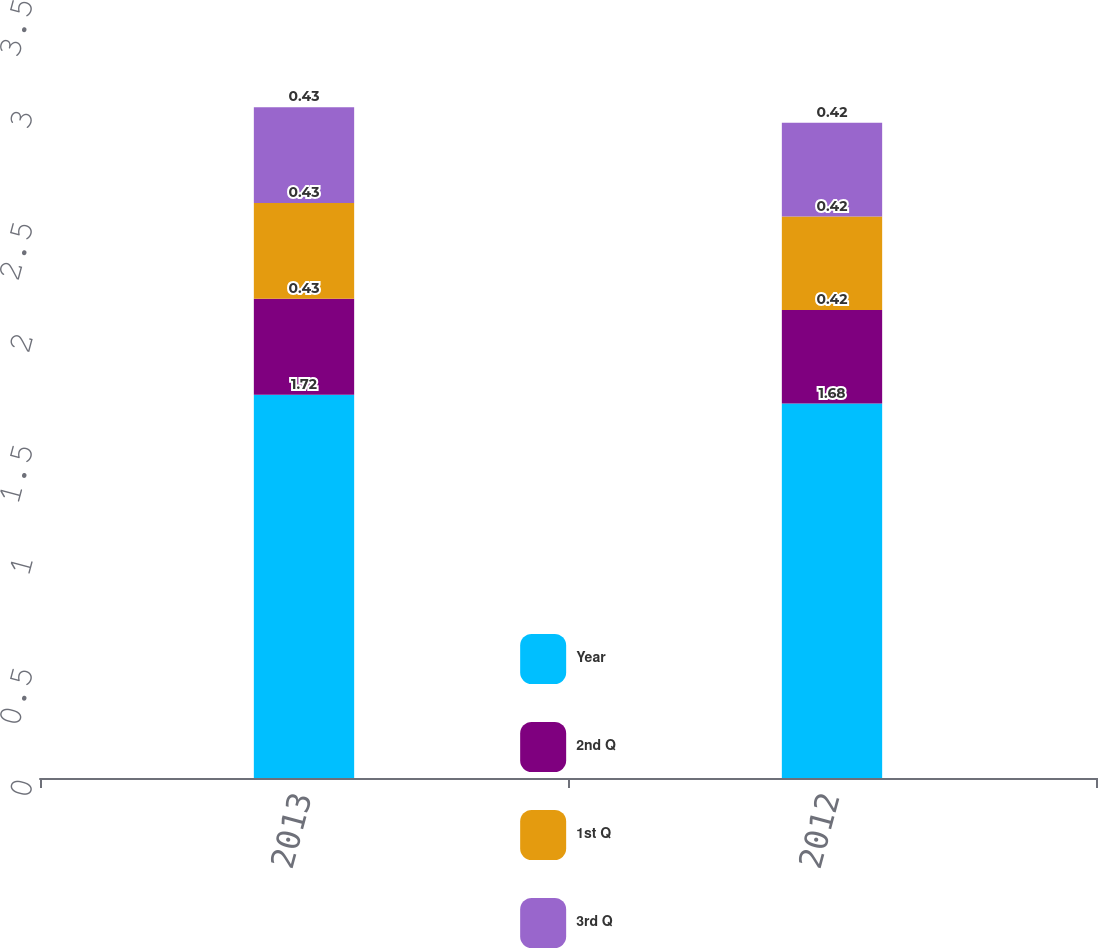Convert chart to OTSL. <chart><loc_0><loc_0><loc_500><loc_500><stacked_bar_chart><ecel><fcel>2013<fcel>2012<nl><fcel>Year<fcel>1.72<fcel>1.68<nl><fcel>2nd Q<fcel>0.43<fcel>0.42<nl><fcel>1st Q<fcel>0.43<fcel>0.42<nl><fcel>3rd Q<fcel>0.43<fcel>0.42<nl></chart> 